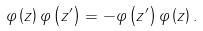Convert formula to latex. <formula><loc_0><loc_0><loc_500><loc_500>\varphi \left ( z \right ) \varphi \left ( z ^ { \prime } \right ) = - \varphi \left ( z ^ { \prime } \right ) \varphi \left ( z \right ) .</formula> 